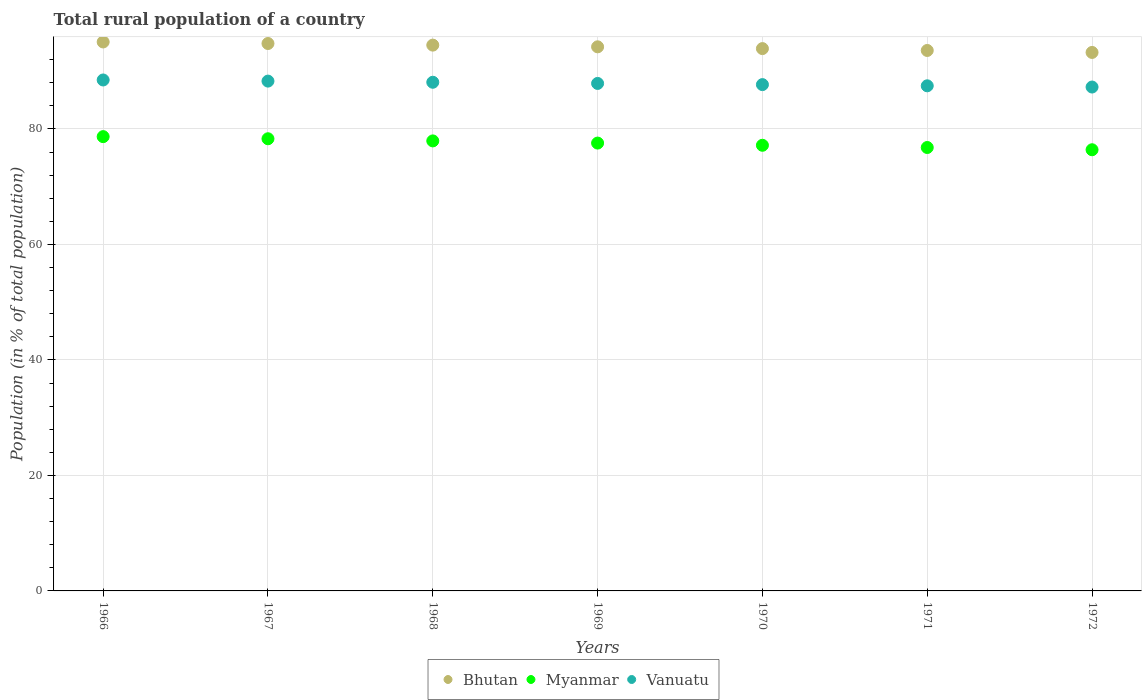How many different coloured dotlines are there?
Offer a very short reply. 3. What is the rural population in Bhutan in 1972?
Keep it short and to the point. 93.25. Across all years, what is the maximum rural population in Myanmar?
Your answer should be compact. 78.67. Across all years, what is the minimum rural population in Bhutan?
Offer a terse response. 93.25. In which year was the rural population in Bhutan maximum?
Provide a short and direct response. 1966. In which year was the rural population in Bhutan minimum?
Offer a very short reply. 1972. What is the total rural population in Myanmar in the graph?
Provide a succinct answer. 542.79. What is the difference between the rural population in Bhutan in 1969 and that in 1970?
Your answer should be very brief. 0.31. What is the difference between the rural population in Vanuatu in 1969 and the rural population in Bhutan in 1968?
Your answer should be compact. -6.63. What is the average rural population in Myanmar per year?
Ensure brevity in your answer.  77.54. In the year 1967, what is the difference between the rural population in Myanmar and rural population in Vanuatu?
Make the answer very short. -9.98. What is the ratio of the rural population in Vanuatu in 1971 to that in 1972?
Your answer should be very brief. 1. Is the rural population in Bhutan in 1967 less than that in 1969?
Provide a succinct answer. No. What is the difference between the highest and the second highest rural population in Vanuatu?
Provide a succinct answer. 0.2. What is the difference between the highest and the lowest rural population in Myanmar?
Your answer should be compact. 2.27. Is the sum of the rural population in Vanuatu in 1970 and 1971 greater than the maximum rural population in Myanmar across all years?
Keep it short and to the point. Yes. Does the rural population in Bhutan monotonically increase over the years?
Keep it short and to the point. No. Is the rural population in Bhutan strictly greater than the rural population in Vanuatu over the years?
Provide a short and direct response. Yes. Is the rural population in Vanuatu strictly less than the rural population in Myanmar over the years?
Your response must be concise. No. What is the difference between two consecutive major ticks on the Y-axis?
Provide a short and direct response. 20. Are the values on the major ticks of Y-axis written in scientific E-notation?
Provide a short and direct response. No. Does the graph contain any zero values?
Provide a succinct answer. No. What is the title of the graph?
Give a very brief answer. Total rural population of a country. What is the label or title of the X-axis?
Your answer should be very brief. Years. What is the label or title of the Y-axis?
Give a very brief answer. Population (in % of total population). What is the Population (in % of total population) of Bhutan in 1966?
Your answer should be compact. 95.06. What is the Population (in % of total population) of Myanmar in 1966?
Offer a very short reply. 78.67. What is the Population (in % of total population) in Vanuatu in 1966?
Your answer should be very brief. 88.48. What is the Population (in % of total population) in Bhutan in 1967?
Give a very brief answer. 94.79. What is the Population (in % of total population) in Myanmar in 1967?
Ensure brevity in your answer.  78.3. What is the Population (in % of total population) in Vanuatu in 1967?
Ensure brevity in your answer.  88.28. What is the Population (in % of total population) of Bhutan in 1968?
Offer a very short reply. 94.51. What is the Population (in % of total population) in Myanmar in 1968?
Offer a terse response. 77.93. What is the Population (in % of total population) in Vanuatu in 1968?
Ensure brevity in your answer.  88.08. What is the Population (in % of total population) of Bhutan in 1969?
Offer a very short reply. 94.22. What is the Population (in % of total population) in Myanmar in 1969?
Offer a very short reply. 77.55. What is the Population (in % of total population) of Vanuatu in 1969?
Ensure brevity in your answer.  87.88. What is the Population (in % of total population) in Bhutan in 1970?
Provide a succinct answer. 93.91. What is the Population (in % of total population) of Myanmar in 1970?
Provide a succinct answer. 77.17. What is the Population (in % of total population) of Vanuatu in 1970?
Provide a short and direct response. 87.67. What is the Population (in % of total population) of Bhutan in 1971?
Make the answer very short. 93.59. What is the Population (in % of total population) of Myanmar in 1971?
Make the answer very short. 76.78. What is the Population (in % of total population) in Vanuatu in 1971?
Your answer should be compact. 87.47. What is the Population (in % of total population) in Bhutan in 1972?
Offer a terse response. 93.25. What is the Population (in % of total population) in Myanmar in 1972?
Your answer should be compact. 76.39. What is the Population (in % of total population) of Vanuatu in 1972?
Your answer should be compact. 87.26. Across all years, what is the maximum Population (in % of total population) in Bhutan?
Offer a terse response. 95.06. Across all years, what is the maximum Population (in % of total population) of Myanmar?
Your response must be concise. 78.67. Across all years, what is the maximum Population (in % of total population) of Vanuatu?
Ensure brevity in your answer.  88.48. Across all years, what is the minimum Population (in % of total population) of Bhutan?
Give a very brief answer. 93.25. Across all years, what is the minimum Population (in % of total population) of Myanmar?
Provide a succinct answer. 76.39. Across all years, what is the minimum Population (in % of total population) in Vanuatu?
Provide a succinct answer. 87.26. What is the total Population (in % of total population) of Bhutan in the graph?
Offer a terse response. 659.33. What is the total Population (in % of total population) in Myanmar in the graph?
Offer a terse response. 542.79. What is the total Population (in % of total population) in Vanuatu in the graph?
Give a very brief answer. 615.12. What is the difference between the Population (in % of total population) in Bhutan in 1966 and that in 1967?
Make the answer very short. 0.27. What is the difference between the Population (in % of total population) in Myanmar in 1966 and that in 1967?
Your answer should be compact. 0.37. What is the difference between the Population (in % of total population) of Vanuatu in 1966 and that in 1967?
Offer a terse response. 0.2. What is the difference between the Population (in % of total population) in Bhutan in 1966 and that in 1968?
Your answer should be very brief. 0.55. What is the difference between the Population (in % of total population) of Myanmar in 1966 and that in 1968?
Ensure brevity in your answer.  0.74. What is the difference between the Population (in % of total population) of Vanuatu in 1966 and that in 1968?
Your answer should be very brief. 0.4. What is the difference between the Population (in % of total population) in Bhutan in 1966 and that in 1969?
Offer a terse response. 0.84. What is the difference between the Population (in % of total population) of Myanmar in 1966 and that in 1969?
Ensure brevity in your answer.  1.11. What is the difference between the Population (in % of total population) in Vanuatu in 1966 and that in 1969?
Ensure brevity in your answer.  0.6. What is the difference between the Population (in % of total population) of Bhutan in 1966 and that in 1970?
Give a very brief answer. 1.15. What is the difference between the Population (in % of total population) in Myanmar in 1966 and that in 1970?
Ensure brevity in your answer.  1.5. What is the difference between the Population (in % of total population) in Vanuatu in 1966 and that in 1970?
Make the answer very short. 0.8. What is the difference between the Population (in % of total population) of Bhutan in 1966 and that in 1971?
Provide a short and direct response. 1.47. What is the difference between the Population (in % of total population) of Myanmar in 1966 and that in 1971?
Offer a very short reply. 1.88. What is the difference between the Population (in % of total population) of Vanuatu in 1966 and that in 1971?
Provide a short and direct response. 1.01. What is the difference between the Population (in % of total population) in Bhutan in 1966 and that in 1972?
Keep it short and to the point. 1.81. What is the difference between the Population (in % of total population) of Myanmar in 1966 and that in 1972?
Your response must be concise. 2.27. What is the difference between the Population (in % of total population) of Vanuatu in 1966 and that in 1972?
Give a very brief answer. 1.22. What is the difference between the Population (in % of total population) in Bhutan in 1967 and that in 1968?
Your answer should be very brief. 0.28. What is the difference between the Population (in % of total population) in Myanmar in 1967 and that in 1968?
Keep it short and to the point. 0.37. What is the difference between the Population (in % of total population) of Bhutan in 1967 and that in 1969?
Your answer should be very brief. 0.57. What is the difference between the Population (in % of total population) of Myanmar in 1967 and that in 1969?
Provide a succinct answer. 0.75. What is the difference between the Population (in % of total population) in Vanuatu in 1967 and that in 1969?
Give a very brief answer. 0.4. What is the difference between the Population (in % of total population) of Bhutan in 1967 and that in 1970?
Your answer should be compact. 0.88. What is the difference between the Population (in % of total population) in Myanmar in 1967 and that in 1970?
Give a very brief answer. 1.13. What is the difference between the Population (in % of total population) in Vanuatu in 1967 and that in 1970?
Provide a succinct answer. 0.61. What is the difference between the Population (in % of total population) in Bhutan in 1967 and that in 1971?
Your answer should be compact. 1.21. What is the difference between the Population (in % of total population) of Myanmar in 1967 and that in 1971?
Your answer should be very brief. 1.51. What is the difference between the Population (in % of total population) of Vanuatu in 1967 and that in 1971?
Ensure brevity in your answer.  0.81. What is the difference between the Population (in % of total population) of Bhutan in 1967 and that in 1972?
Your response must be concise. 1.55. What is the difference between the Population (in % of total population) in Myanmar in 1967 and that in 1972?
Provide a succinct answer. 1.91. What is the difference between the Population (in % of total population) in Bhutan in 1968 and that in 1969?
Keep it short and to the point. 0.29. What is the difference between the Population (in % of total population) in Myanmar in 1968 and that in 1969?
Make the answer very short. 0.38. What is the difference between the Population (in % of total population) in Vanuatu in 1968 and that in 1969?
Your response must be concise. 0.2. What is the difference between the Population (in % of total population) of Bhutan in 1968 and that in 1970?
Provide a succinct answer. 0.6. What is the difference between the Population (in % of total population) in Myanmar in 1968 and that in 1970?
Make the answer very short. 0.76. What is the difference between the Population (in % of total population) of Vanuatu in 1968 and that in 1970?
Provide a short and direct response. 0.41. What is the difference between the Population (in % of total population) of Bhutan in 1968 and that in 1971?
Offer a terse response. 0.93. What is the difference between the Population (in % of total population) in Myanmar in 1968 and that in 1971?
Ensure brevity in your answer.  1.14. What is the difference between the Population (in % of total population) in Vanuatu in 1968 and that in 1971?
Ensure brevity in your answer.  0.61. What is the difference between the Population (in % of total population) in Bhutan in 1968 and that in 1972?
Offer a terse response. 1.27. What is the difference between the Population (in % of total population) of Myanmar in 1968 and that in 1972?
Your answer should be very brief. 1.53. What is the difference between the Population (in % of total population) of Vanuatu in 1968 and that in 1972?
Your response must be concise. 0.83. What is the difference between the Population (in % of total population) in Bhutan in 1969 and that in 1970?
Provide a succinct answer. 0.31. What is the difference between the Population (in % of total population) in Myanmar in 1969 and that in 1970?
Provide a short and direct response. 0.38. What is the difference between the Population (in % of total population) in Vanuatu in 1969 and that in 1970?
Provide a short and direct response. 0.2. What is the difference between the Population (in % of total population) in Bhutan in 1969 and that in 1971?
Ensure brevity in your answer.  0.63. What is the difference between the Population (in % of total population) in Myanmar in 1969 and that in 1971?
Give a very brief answer. 0.77. What is the difference between the Population (in % of total population) of Vanuatu in 1969 and that in 1971?
Make the answer very short. 0.41. What is the difference between the Population (in % of total population) in Myanmar in 1969 and that in 1972?
Offer a very short reply. 1.16. What is the difference between the Population (in % of total population) of Vanuatu in 1969 and that in 1972?
Make the answer very short. 0.62. What is the difference between the Population (in % of total population) of Bhutan in 1970 and that in 1971?
Offer a very short reply. 0.32. What is the difference between the Population (in % of total population) of Myanmar in 1970 and that in 1971?
Your response must be concise. 0.39. What is the difference between the Population (in % of total population) of Vanuatu in 1970 and that in 1971?
Your answer should be very brief. 0.21. What is the difference between the Population (in % of total population) in Bhutan in 1970 and that in 1972?
Offer a very short reply. 0.67. What is the difference between the Population (in % of total population) of Myanmar in 1970 and that in 1972?
Give a very brief answer. 0.78. What is the difference between the Population (in % of total population) of Vanuatu in 1970 and that in 1972?
Make the answer very short. 0.42. What is the difference between the Population (in % of total population) of Bhutan in 1971 and that in 1972?
Offer a very short reply. 0.34. What is the difference between the Population (in % of total population) in Myanmar in 1971 and that in 1972?
Your answer should be very brief. 0.39. What is the difference between the Population (in % of total population) of Vanuatu in 1971 and that in 1972?
Keep it short and to the point. 0.21. What is the difference between the Population (in % of total population) of Bhutan in 1966 and the Population (in % of total population) of Myanmar in 1967?
Give a very brief answer. 16.76. What is the difference between the Population (in % of total population) in Bhutan in 1966 and the Population (in % of total population) in Vanuatu in 1967?
Your answer should be very brief. 6.78. What is the difference between the Population (in % of total population) of Myanmar in 1966 and the Population (in % of total population) of Vanuatu in 1967?
Offer a very short reply. -9.62. What is the difference between the Population (in % of total population) of Bhutan in 1966 and the Population (in % of total population) of Myanmar in 1968?
Your answer should be very brief. 17.13. What is the difference between the Population (in % of total population) in Bhutan in 1966 and the Population (in % of total population) in Vanuatu in 1968?
Ensure brevity in your answer.  6.98. What is the difference between the Population (in % of total population) in Myanmar in 1966 and the Population (in % of total population) in Vanuatu in 1968?
Your answer should be compact. -9.42. What is the difference between the Population (in % of total population) of Bhutan in 1966 and the Population (in % of total population) of Myanmar in 1969?
Provide a short and direct response. 17.51. What is the difference between the Population (in % of total population) in Bhutan in 1966 and the Population (in % of total population) in Vanuatu in 1969?
Give a very brief answer. 7.18. What is the difference between the Population (in % of total population) of Myanmar in 1966 and the Population (in % of total population) of Vanuatu in 1969?
Your answer should be compact. -9.21. What is the difference between the Population (in % of total population) in Bhutan in 1966 and the Population (in % of total population) in Myanmar in 1970?
Make the answer very short. 17.89. What is the difference between the Population (in % of total population) in Bhutan in 1966 and the Population (in % of total population) in Vanuatu in 1970?
Offer a very short reply. 7.38. What is the difference between the Population (in % of total population) in Myanmar in 1966 and the Population (in % of total population) in Vanuatu in 1970?
Your answer should be compact. -9.01. What is the difference between the Population (in % of total population) of Bhutan in 1966 and the Population (in % of total population) of Myanmar in 1971?
Make the answer very short. 18.27. What is the difference between the Population (in % of total population) of Bhutan in 1966 and the Population (in % of total population) of Vanuatu in 1971?
Offer a very short reply. 7.59. What is the difference between the Population (in % of total population) of Myanmar in 1966 and the Population (in % of total population) of Vanuatu in 1971?
Your answer should be very brief. -8.8. What is the difference between the Population (in % of total population) in Bhutan in 1966 and the Population (in % of total population) in Myanmar in 1972?
Your answer should be compact. 18.67. What is the difference between the Population (in % of total population) of Bhutan in 1966 and the Population (in % of total population) of Vanuatu in 1972?
Offer a terse response. 7.8. What is the difference between the Population (in % of total population) of Myanmar in 1966 and the Population (in % of total population) of Vanuatu in 1972?
Your answer should be very brief. -8.59. What is the difference between the Population (in % of total population) of Bhutan in 1967 and the Population (in % of total population) of Myanmar in 1968?
Offer a very short reply. 16.87. What is the difference between the Population (in % of total population) of Bhutan in 1967 and the Population (in % of total population) of Vanuatu in 1968?
Offer a very short reply. 6.71. What is the difference between the Population (in % of total population) of Myanmar in 1967 and the Population (in % of total population) of Vanuatu in 1968?
Give a very brief answer. -9.78. What is the difference between the Population (in % of total population) of Bhutan in 1967 and the Population (in % of total population) of Myanmar in 1969?
Offer a terse response. 17.24. What is the difference between the Population (in % of total population) of Bhutan in 1967 and the Population (in % of total population) of Vanuatu in 1969?
Your answer should be very brief. 6.91. What is the difference between the Population (in % of total population) in Myanmar in 1967 and the Population (in % of total population) in Vanuatu in 1969?
Give a very brief answer. -9.58. What is the difference between the Population (in % of total population) of Bhutan in 1967 and the Population (in % of total population) of Myanmar in 1970?
Offer a terse response. 17.62. What is the difference between the Population (in % of total population) in Bhutan in 1967 and the Population (in % of total population) in Vanuatu in 1970?
Make the answer very short. 7.12. What is the difference between the Population (in % of total population) in Myanmar in 1967 and the Population (in % of total population) in Vanuatu in 1970?
Ensure brevity in your answer.  -9.38. What is the difference between the Population (in % of total population) in Bhutan in 1967 and the Population (in % of total population) in Myanmar in 1971?
Your answer should be compact. 18.01. What is the difference between the Population (in % of total population) in Bhutan in 1967 and the Population (in % of total population) in Vanuatu in 1971?
Provide a short and direct response. 7.33. What is the difference between the Population (in % of total population) in Myanmar in 1967 and the Population (in % of total population) in Vanuatu in 1971?
Make the answer very short. -9.17. What is the difference between the Population (in % of total population) in Bhutan in 1967 and the Population (in % of total population) in Myanmar in 1972?
Give a very brief answer. 18.4. What is the difference between the Population (in % of total population) in Bhutan in 1967 and the Population (in % of total population) in Vanuatu in 1972?
Your answer should be very brief. 7.54. What is the difference between the Population (in % of total population) of Myanmar in 1967 and the Population (in % of total population) of Vanuatu in 1972?
Your answer should be very brief. -8.96. What is the difference between the Population (in % of total population) in Bhutan in 1968 and the Population (in % of total population) in Myanmar in 1969?
Give a very brief answer. 16.96. What is the difference between the Population (in % of total population) in Bhutan in 1968 and the Population (in % of total population) in Vanuatu in 1969?
Provide a succinct answer. 6.63. What is the difference between the Population (in % of total population) in Myanmar in 1968 and the Population (in % of total population) in Vanuatu in 1969?
Your response must be concise. -9.95. What is the difference between the Population (in % of total population) in Bhutan in 1968 and the Population (in % of total population) in Myanmar in 1970?
Offer a very short reply. 17.34. What is the difference between the Population (in % of total population) in Bhutan in 1968 and the Population (in % of total population) in Vanuatu in 1970?
Offer a very short reply. 6.84. What is the difference between the Population (in % of total population) in Myanmar in 1968 and the Population (in % of total population) in Vanuatu in 1970?
Give a very brief answer. -9.75. What is the difference between the Population (in % of total population) in Bhutan in 1968 and the Population (in % of total population) in Myanmar in 1971?
Your answer should be compact. 17.73. What is the difference between the Population (in % of total population) of Bhutan in 1968 and the Population (in % of total population) of Vanuatu in 1971?
Keep it short and to the point. 7.05. What is the difference between the Population (in % of total population) of Myanmar in 1968 and the Population (in % of total population) of Vanuatu in 1971?
Your answer should be very brief. -9.54. What is the difference between the Population (in % of total population) of Bhutan in 1968 and the Population (in % of total population) of Myanmar in 1972?
Your answer should be compact. 18.12. What is the difference between the Population (in % of total population) in Bhutan in 1968 and the Population (in % of total population) in Vanuatu in 1972?
Your response must be concise. 7.26. What is the difference between the Population (in % of total population) of Myanmar in 1968 and the Population (in % of total population) of Vanuatu in 1972?
Give a very brief answer. -9.33. What is the difference between the Population (in % of total population) in Bhutan in 1969 and the Population (in % of total population) in Myanmar in 1970?
Provide a succinct answer. 17.05. What is the difference between the Population (in % of total population) of Bhutan in 1969 and the Population (in % of total population) of Vanuatu in 1970?
Make the answer very short. 6.54. What is the difference between the Population (in % of total population) in Myanmar in 1969 and the Population (in % of total population) in Vanuatu in 1970?
Offer a terse response. -10.12. What is the difference between the Population (in % of total population) of Bhutan in 1969 and the Population (in % of total population) of Myanmar in 1971?
Keep it short and to the point. 17.43. What is the difference between the Population (in % of total population) of Bhutan in 1969 and the Population (in % of total population) of Vanuatu in 1971?
Keep it short and to the point. 6.75. What is the difference between the Population (in % of total population) in Myanmar in 1969 and the Population (in % of total population) in Vanuatu in 1971?
Make the answer very short. -9.92. What is the difference between the Population (in % of total population) in Bhutan in 1969 and the Population (in % of total population) in Myanmar in 1972?
Provide a short and direct response. 17.82. What is the difference between the Population (in % of total population) in Bhutan in 1969 and the Population (in % of total population) in Vanuatu in 1972?
Your response must be concise. 6.96. What is the difference between the Population (in % of total population) of Myanmar in 1969 and the Population (in % of total population) of Vanuatu in 1972?
Provide a short and direct response. -9.71. What is the difference between the Population (in % of total population) in Bhutan in 1970 and the Population (in % of total population) in Myanmar in 1971?
Offer a terse response. 17.13. What is the difference between the Population (in % of total population) in Bhutan in 1970 and the Population (in % of total population) in Vanuatu in 1971?
Offer a terse response. 6.44. What is the difference between the Population (in % of total population) in Myanmar in 1970 and the Population (in % of total population) in Vanuatu in 1971?
Ensure brevity in your answer.  -10.3. What is the difference between the Population (in % of total population) of Bhutan in 1970 and the Population (in % of total population) of Myanmar in 1972?
Offer a terse response. 17.52. What is the difference between the Population (in % of total population) of Bhutan in 1970 and the Population (in % of total population) of Vanuatu in 1972?
Your answer should be very brief. 6.66. What is the difference between the Population (in % of total population) in Myanmar in 1970 and the Population (in % of total population) in Vanuatu in 1972?
Offer a terse response. -10.09. What is the difference between the Population (in % of total population) in Bhutan in 1971 and the Population (in % of total population) in Myanmar in 1972?
Provide a succinct answer. 17.19. What is the difference between the Population (in % of total population) in Bhutan in 1971 and the Population (in % of total population) in Vanuatu in 1972?
Your response must be concise. 6.33. What is the difference between the Population (in % of total population) of Myanmar in 1971 and the Population (in % of total population) of Vanuatu in 1972?
Provide a succinct answer. -10.47. What is the average Population (in % of total population) in Bhutan per year?
Ensure brevity in your answer.  94.19. What is the average Population (in % of total population) in Myanmar per year?
Offer a very short reply. 77.54. What is the average Population (in % of total population) of Vanuatu per year?
Offer a terse response. 87.87. In the year 1966, what is the difference between the Population (in % of total population) in Bhutan and Population (in % of total population) in Myanmar?
Provide a short and direct response. 16.39. In the year 1966, what is the difference between the Population (in % of total population) of Bhutan and Population (in % of total population) of Vanuatu?
Your answer should be compact. 6.58. In the year 1966, what is the difference between the Population (in % of total population) of Myanmar and Population (in % of total population) of Vanuatu?
Offer a very short reply. -9.81. In the year 1967, what is the difference between the Population (in % of total population) in Bhutan and Population (in % of total population) in Myanmar?
Offer a terse response. 16.49. In the year 1967, what is the difference between the Population (in % of total population) of Bhutan and Population (in % of total population) of Vanuatu?
Your response must be concise. 6.51. In the year 1967, what is the difference between the Population (in % of total population) in Myanmar and Population (in % of total population) in Vanuatu?
Provide a succinct answer. -9.98. In the year 1968, what is the difference between the Population (in % of total population) of Bhutan and Population (in % of total population) of Myanmar?
Make the answer very short. 16.59. In the year 1968, what is the difference between the Population (in % of total population) in Bhutan and Population (in % of total population) in Vanuatu?
Give a very brief answer. 6.43. In the year 1968, what is the difference between the Population (in % of total population) of Myanmar and Population (in % of total population) of Vanuatu?
Provide a short and direct response. -10.15. In the year 1969, what is the difference between the Population (in % of total population) in Bhutan and Population (in % of total population) in Myanmar?
Make the answer very short. 16.67. In the year 1969, what is the difference between the Population (in % of total population) of Bhutan and Population (in % of total population) of Vanuatu?
Provide a short and direct response. 6.34. In the year 1969, what is the difference between the Population (in % of total population) in Myanmar and Population (in % of total population) in Vanuatu?
Offer a terse response. -10.33. In the year 1970, what is the difference between the Population (in % of total population) of Bhutan and Population (in % of total population) of Myanmar?
Your answer should be compact. 16.74. In the year 1970, what is the difference between the Population (in % of total population) of Bhutan and Population (in % of total population) of Vanuatu?
Your answer should be compact. 6.24. In the year 1970, what is the difference between the Population (in % of total population) of Myanmar and Population (in % of total population) of Vanuatu?
Keep it short and to the point. -10.51. In the year 1971, what is the difference between the Population (in % of total population) in Bhutan and Population (in % of total population) in Myanmar?
Offer a very short reply. 16.8. In the year 1971, what is the difference between the Population (in % of total population) of Bhutan and Population (in % of total population) of Vanuatu?
Your answer should be compact. 6.12. In the year 1971, what is the difference between the Population (in % of total population) in Myanmar and Population (in % of total population) in Vanuatu?
Your answer should be compact. -10.68. In the year 1972, what is the difference between the Population (in % of total population) in Bhutan and Population (in % of total population) in Myanmar?
Offer a terse response. 16.85. In the year 1972, what is the difference between the Population (in % of total population) in Bhutan and Population (in % of total population) in Vanuatu?
Offer a very short reply. 5.99. In the year 1972, what is the difference between the Population (in % of total population) in Myanmar and Population (in % of total population) in Vanuatu?
Offer a terse response. -10.86. What is the ratio of the Population (in % of total population) of Bhutan in 1966 to that in 1967?
Your answer should be compact. 1. What is the ratio of the Population (in % of total population) of Myanmar in 1966 to that in 1967?
Offer a very short reply. 1. What is the ratio of the Population (in % of total population) of Myanmar in 1966 to that in 1968?
Ensure brevity in your answer.  1.01. What is the ratio of the Population (in % of total population) in Bhutan in 1966 to that in 1969?
Provide a short and direct response. 1.01. What is the ratio of the Population (in % of total population) in Myanmar in 1966 to that in 1969?
Provide a short and direct response. 1.01. What is the ratio of the Population (in % of total population) in Vanuatu in 1966 to that in 1969?
Your answer should be very brief. 1.01. What is the ratio of the Population (in % of total population) in Bhutan in 1966 to that in 1970?
Provide a succinct answer. 1.01. What is the ratio of the Population (in % of total population) of Myanmar in 1966 to that in 1970?
Ensure brevity in your answer.  1.02. What is the ratio of the Population (in % of total population) in Vanuatu in 1966 to that in 1970?
Give a very brief answer. 1.01. What is the ratio of the Population (in % of total population) of Bhutan in 1966 to that in 1971?
Provide a succinct answer. 1.02. What is the ratio of the Population (in % of total population) in Myanmar in 1966 to that in 1971?
Make the answer very short. 1.02. What is the ratio of the Population (in % of total population) in Vanuatu in 1966 to that in 1971?
Make the answer very short. 1.01. What is the ratio of the Population (in % of total population) in Bhutan in 1966 to that in 1972?
Provide a succinct answer. 1.02. What is the ratio of the Population (in % of total population) of Myanmar in 1966 to that in 1972?
Ensure brevity in your answer.  1.03. What is the ratio of the Population (in % of total population) in Vanuatu in 1966 to that in 1972?
Ensure brevity in your answer.  1.01. What is the ratio of the Population (in % of total population) of Myanmar in 1967 to that in 1968?
Offer a very short reply. 1. What is the ratio of the Population (in % of total population) of Myanmar in 1967 to that in 1969?
Your answer should be very brief. 1.01. What is the ratio of the Population (in % of total population) of Bhutan in 1967 to that in 1970?
Make the answer very short. 1.01. What is the ratio of the Population (in % of total population) of Myanmar in 1967 to that in 1970?
Your answer should be very brief. 1.01. What is the ratio of the Population (in % of total population) in Vanuatu in 1967 to that in 1970?
Your response must be concise. 1.01. What is the ratio of the Population (in % of total population) of Bhutan in 1967 to that in 1971?
Your answer should be compact. 1.01. What is the ratio of the Population (in % of total population) in Myanmar in 1967 to that in 1971?
Your answer should be compact. 1.02. What is the ratio of the Population (in % of total population) of Vanuatu in 1967 to that in 1971?
Keep it short and to the point. 1.01. What is the ratio of the Population (in % of total population) in Bhutan in 1967 to that in 1972?
Give a very brief answer. 1.02. What is the ratio of the Population (in % of total population) of Myanmar in 1967 to that in 1972?
Offer a terse response. 1.02. What is the ratio of the Population (in % of total population) of Vanuatu in 1967 to that in 1972?
Offer a terse response. 1.01. What is the ratio of the Population (in % of total population) in Vanuatu in 1968 to that in 1969?
Keep it short and to the point. 1. What is the ratio of the Population (in % of total population) in Bhutan in 1968 to that in 1970?
Make the answer very short. 1.01. What is the ratio of the Population (in % of total population) in Myanmar in 1968 to that in 1970?
Your answer should be compact. 1.01. What is the ratio of the Population (in % of total population) in Bhutan in 1968 to that in 1971?
Your answer should be compact. 1.01. What is the ratio of the Population (in % of total population) of Myanmar in 1968 to that in 1971?
Provide a short and direct response. 1.01. What is the ratio of the Population (in % of total population) in Vanuatu in 1968 to that in 1971?
Provide a short and direct response. 1.01. What is the ratio of the Population (in % of total population) in Bhutan in 1968 to that in 1972?
Ensure brevity in your answer.  1.01. What is the ratio of the Population (in % of total population) of Myanmar in 1968 to that in 1972?
Ensure brevity in your answer.  1.02. What is the ratio of the Population (in % of total population) of Vanuatu in 1968 to that in 1972?
Your answer should be compact. 1.01. What is the ratio of the Population (in % of total population) of Bhutan in 1969 to that in 1970?
Provide a short and direct response. 1. What is the ratio of the Population (in % of total population) in Bhutan in 1969 to that in 1971?
Your response must be concise. 1.01. What is the ratio of the Population (in % of total population) of Myanmar in 1969 to that in 1971?
Your response must be concise. 1.01. What is the ratio of the Population (in % of total population) of Vanuatu in 1969 to that in 1971?
Ensure brevity in your answer.  1. What is the ratio of the Population (in % of total population) of Bhutan in 1969 to that in 1972?
Provide a succinct answer. 1.01. What is the ratio of the Population (in % of total population) in Myanmar in 1969 to that in 1972?
Offer a very short reply. 1.02. What is the ratio of the Population (in % of total population) of Bhutan in 1970 to that in 1971?
Make the answer very short. 1. What is the ratio of the Population (in % of total population) in Myanmar in 1970 to that in 1971?
Your answer should be very brief. 1. What is the ratio of the Population (in % of total population) in Vanuatu in 1970 to that in 1971?
Give a very brief answer. 1. What is the ratio of the Population (in % of total population) of Bhutan in 1970 to that in 1972?
Your answer should be compact. 1.01. What is the ratio of the Population (in % of total population) of Myanmar in 1970 to that in 1972?
Make the answer very short. 1.01. What is the ratio of the Population (in % of total population) in Vanuatu in 1970 to that in 1972?
Make the answer very short. 1. What is the ratio of the Population (in % of total population) in Myanmar in 1971 to that in 1972?
Give a very brief answer. 1.01. What is the difference between the highest and the second highest Population (in % of total population) in Bhutan?
Your response must be concise. 0.27. What is the difference between the highest and the second highest Population (in % of total population) of Myanmar?
Provide a succinct answer. 0.37. What is the difference between the highest and the second highest Population (in % of total population) of Vanuatu?
Keep it short and to the point. 0.2. What is the difference between the highest and the lowest Population (in % of total population) of Bhutan?
Your answer should be compact. 1.81. What is the difference between the highest and the lowest Population (in % of total population) in Myanmar?
Give a very brief answer. 2.27. What is the difference between the highest and the lowest Population (in % of total population) in Vanuatu?
Your response must be concise. 1.22. 